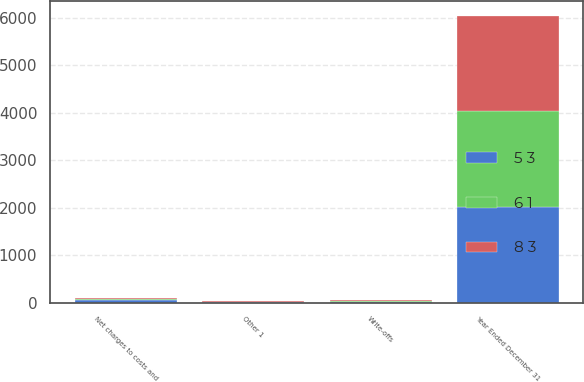Convert chart to OTSL. <chart><loc_0><loc_0><loc_500><loc_500><stacked_bar_chart><ecel><fcel>Year Ended December 31<fcel>Net charges to costs and<fcel>Write-offs<fcel>Other 1<nl><fcel>6 1<fcel>2013<fcel>30<fcel>14<fcel>8<nl><fcel>8 3<fcel>2012<fcel>5<fcel>19<fcel>16<nl><fcel>5 3<fcel>2011<fcel>56<fcel>12<fcel>9<nl></chart> 